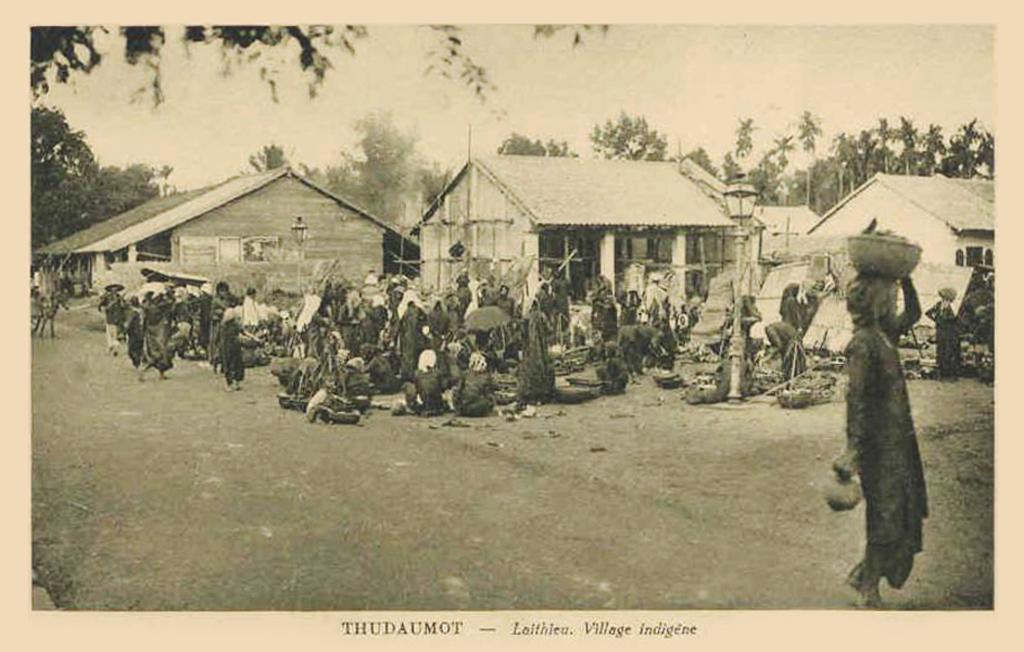How would you summarize this image in a sentence or two? This is an edited image. In this image I can see a crowd of people sitting and standing on the ground. On the right side there is a person carrying a basket on the head and walking. In the background there are few houses and trees. At the top of the image I can see the sky. At the bottom of this image there is some text. This is a black and white picture. 